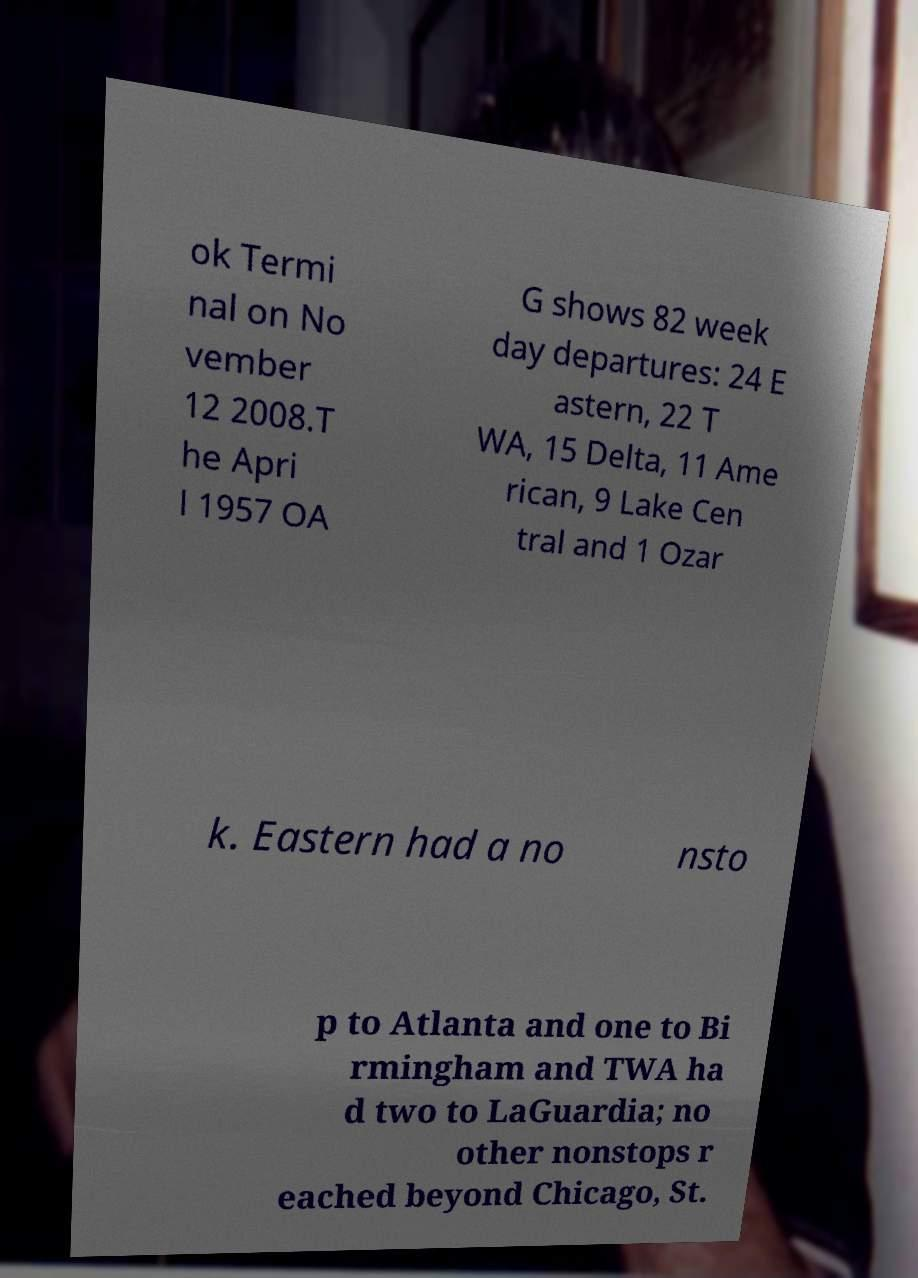Can you read and provide the text displayed in the image?This photo seems to have some interesting text. Can you extract and type it out for me? ok Termi nal on No vember 12 2008.T he Apri l 1957 OA G shows 82 week day departures: 24 E astern, 22 T WA, 15 Delta, 11 Ame rican, 9 Lake Cen tral and 1 Ozar k. Eastern had a no nsto p to Atlanta and one to Bi rmingham and TWA ha d two to LaGuardia; no other nonstops r eached beyond Chicago, St. 